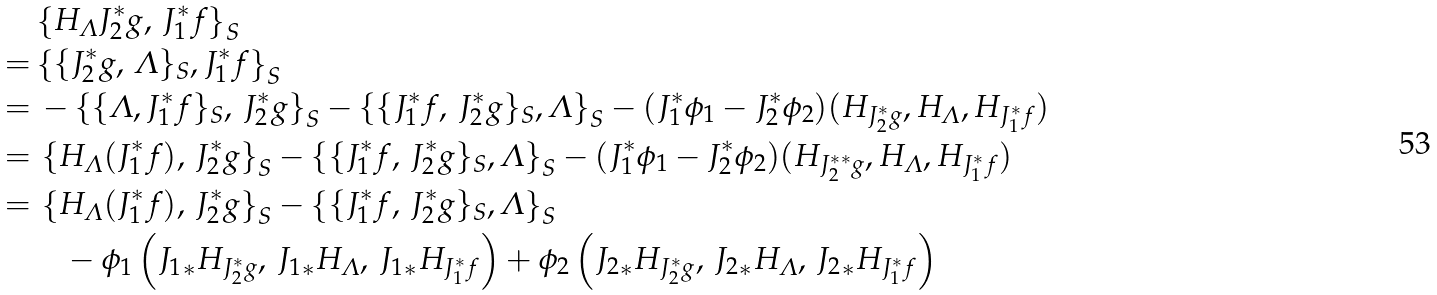<formula> <loc_0><loc_0><loc_500><loc_500>& \left \{ H _ { \varLambda } J _ { 2 } ^ { * } g , \, J _ { 1 } ^ { * } f \right \} _ { S } \\ = & \left \{ \{ J _ { 2 } ^ { * } g , \, \varLambda \} _ { S } , J _ { 1 } ^ { * } f \right \} _ { S } \\ = & \, - \left \{ \{ \varLambda , J _ { 1 } ^ { * } f \} _ { S } , \, J _ { 2 } ^ { * } g \right \} _ { S } - \left \{ \{ J _ { 1 } ^ { * } f , \, J _ { 2 } ^ { * } g \} _ { S } , \varLambda \right \} _ { S } - ( J _ { 1 } ^ { * } \phi _ { 1 } - J _ { 2 } ^ { * } \phi _ { 2 } ) ( H _ { J _ { 2 } ^ { * } g } , H _ { \varLambda } , H _ { J _ { 1 } ^ { * } f } ) \\ = & \, \left \{ H _ { \varLambda } ( J _ { 1 } ^ { * } f ) , \, J _ { 2 } ^ { * } g \right \} _ { S } - \left \{ \{ J _ { 1 } ^ { * } f , \, J _ { 2 } ^ { * } g \} _ { S } , \varLambda \right \} _ { S } - ( J _ { 1 } ^ { * } \phi _ { 1 } - J _ { 2 } ^ { * } \phi _ { 2 } ) ( H _ { J _ { 2 } ^ { * * } g } , H _ { \varLambda } , H _ { J _ { 1 } ^ { * } f } ) \\ = & \, \left \{ H _ { \varLambda } ( J _ { 1 } ^ { * } f ) , \, J _ { 2 } ^ { * } g \right \} _ { S } - \left \{ \{ J _ { 1 } ^ { * } f , \, J _ { 2 } ^ { * } g \} _ { S } , \varLambda \right \} _ { S } \\ & \quad - \phi _ { 1 } \left ( { J _ { 1 } } _ { * } H _ { J _ { 2 } ^ { * } g } , \, { J _ { 1 } } _ { * } H _ { \varLambda } , \, { J _ { 1 } } _ { * } H _ { J _ { 1 } ^ { * } f } \right ) + \phi _ { 2 } \left ( { J _ { 2 } } _ { * } H _ { J _ { 2 } ^ { * } g } , \, { J _ { 2 } } _ { * } H _ { \varLambda } , \, { J _ { 2 } } _ { * } H _ { J _ { 1 } ^ { * } f } \right )</formula> 